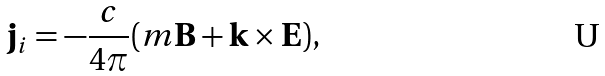<formula> <loc_0><loc_0><loc_500><loc_500>\mathbf j _ { i } = - \frac { c } { 4 \pi } ( m \mathbf B + \mathbf k \times \mathbf E ) ,</formula> 